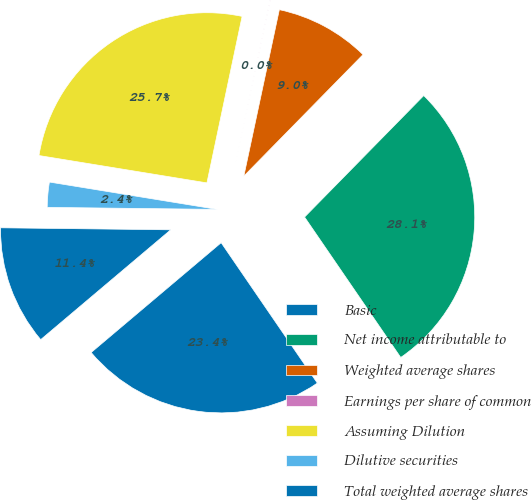<chart> <loc_0><loc_0><loc_500><loc_500><pie_chart><fcel>Basic<fcel>Net income attributable to<fcel>Weighted average shares<fcel>Earnings per share of common<fcel>Assuming Dilution<fcel>Dilutive securities<fcel>Total weighted average shares<nl><fcel>23.39%<fcel>28.09%<fcel>9.0%<fcel>0.03%<fcel>25.74%<fcel>2.38%<fcel>11.35%<nl></chart> 